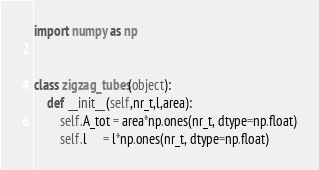Convert code to text. <code><loc_0><loc_0><loc_500><loc_500><_Python_>import numpy as np


class zigzag_tubes(object):
    def __init__(self,nr_t,l,area):
        self.A_tot = area*np.ones(nr_t, dtype=np.float)
        self.l     = l*np.ones(nr_t, dtype=np.float)
</code> 